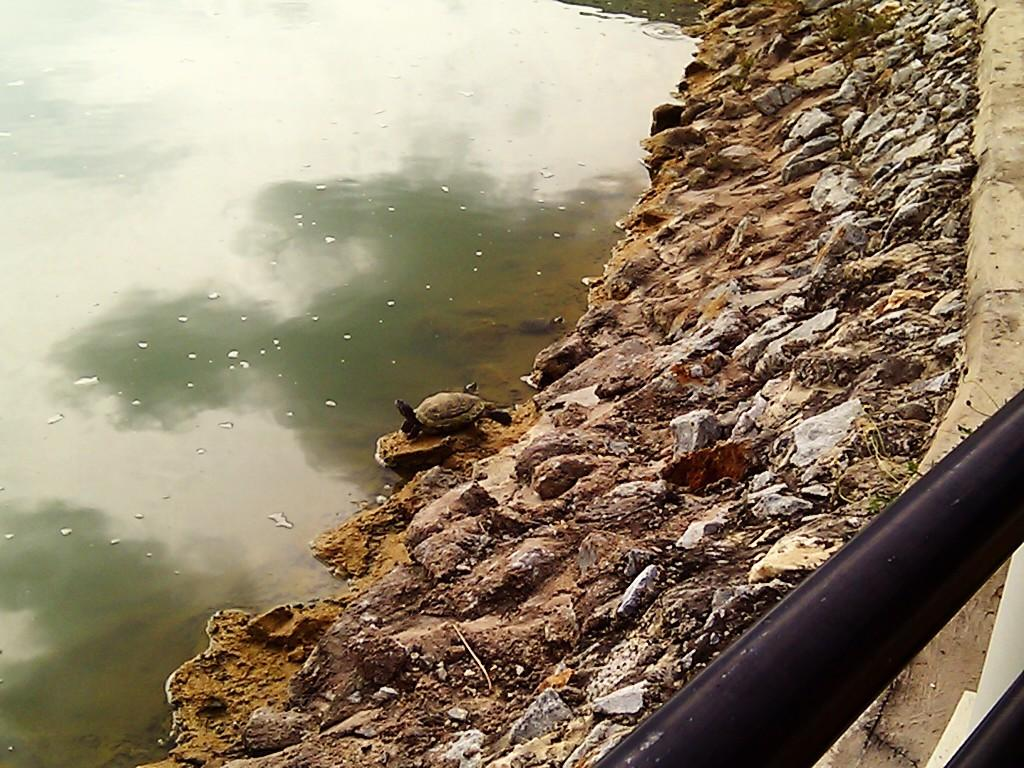What is located on the left side of the image? There is water on the left side of the image. What objects can be seen in the image besides the water? There are stones and a rod on the right side of the image. Is there any living creature present in the image? Yes, there is a tortoise on one of the stones. How many oranges are hanging from the lamp in the image? There is no lamp or oranges present in the image. What day of the week is it in the image? The day of the week cannot be determined from the image. 